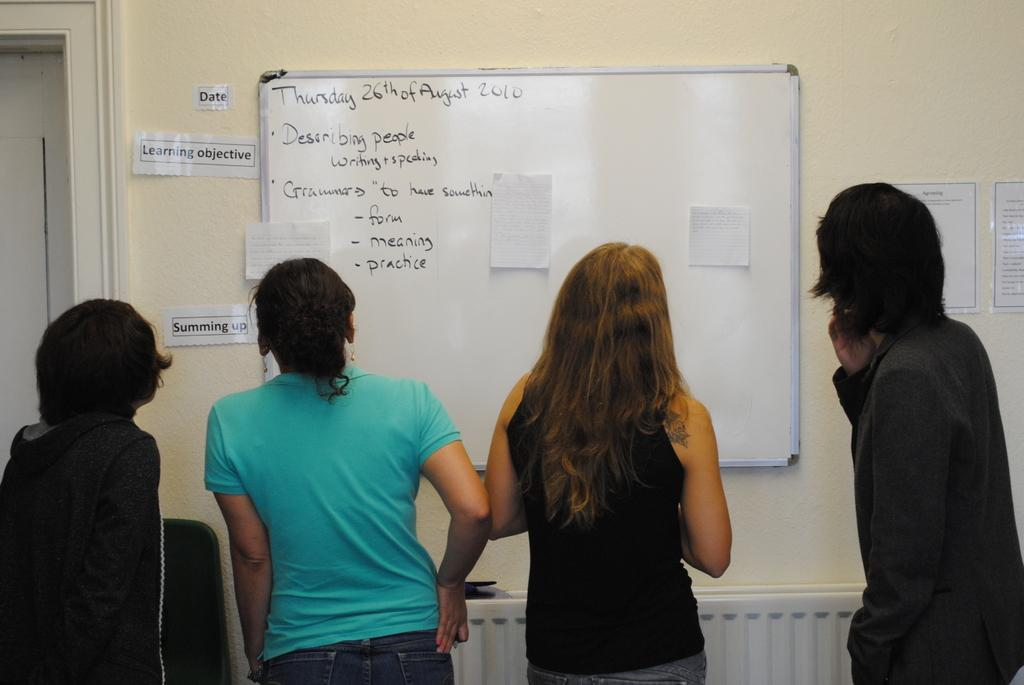<image>
Give a short and clear explanation of the subsequent image. One of the tasks on the whit board is to describe people. 